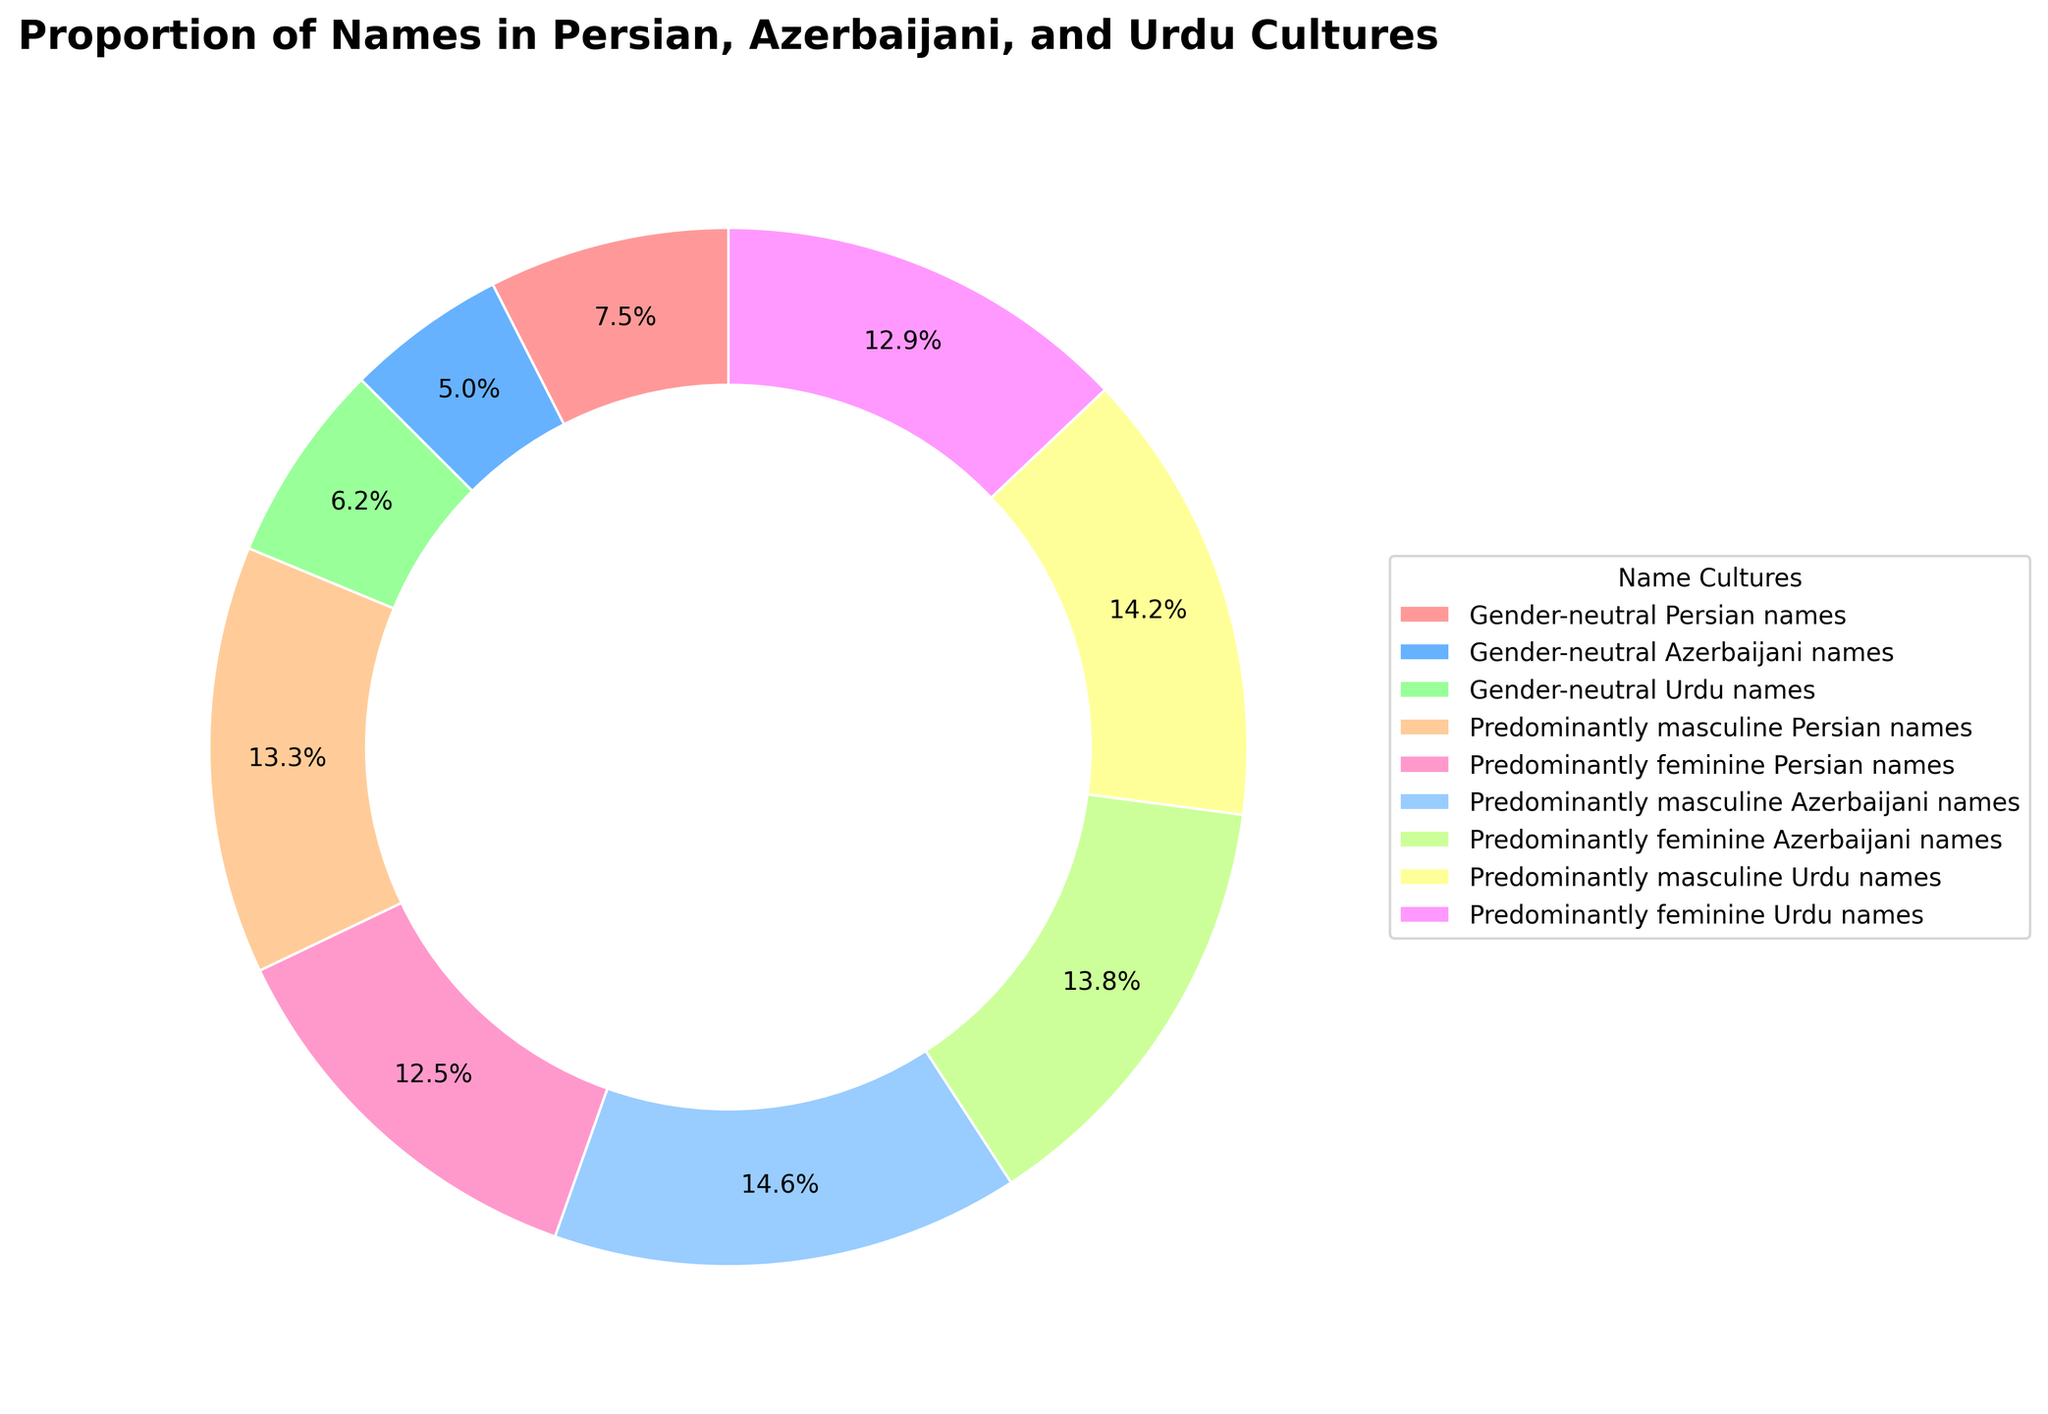What is the percentage of gender-neutral Persian names? The wedge labeled "Gender-neutral Persian names" in the pie chart shows 18%.
Answer: 18% Which culture has the smallest proportion of gender-neutral names? By comparing the wedges labeled "Gender-neutral Persian names", "Gender-neutral Azerbaijani names", and "Gender-neutral Urdu names", we see that Azerbaijani has the smallest at 12%.
Answer: Azerbaijani Is the proportion of gender-neutral Urdu names greater than that of gender-neutral Azerbaijani names? Yes, the wedge for "Gender-neutral Urdu names" is 15%, while "Gender-neutral Azerbaijani names" is 12%, thus Urdu names have a greater proportion.
Answer: Yes What is the combined percentage of predominantly masculine names across all three cultures? Sum the percentages of "Predominantly masculine Persian names" (32%), "Predominantly masculine Azerbaijani names" (35%), and "Predominantly masculine Urdu names" (34%). So, 32% + 35% + 34% = 101%.
Answer: 101% How much more prevalent are predominantly feminine Persian names than gender-neutral Persian names? Subtract the percentage of "Gender-neutral Persian names" (18%) from "Predominantly feminine Persian names" (30%). Thus, 30% - 18% = 12%.
Answer: 12% Which culture has the highest proportion of predominantly feminine names? By examining the wedges labeled for predominantly feminine names, "Predominantly feminine Azerbaijani names" at 33% is the highest.
Answer: Azerbaijani Compare the total percentage of gender-neutral names with the total percentage of predominantly feminine names across all cultures. Which is higher? First, sum the percentages for gender-neutral names: 18% (Persian) + 12% (Azerbaijani) + 15% (Urdu) = 45%. Next, sum the percentages for predominantly feminine names: 30% (Persian) + 33% (Azerbaijani) + 31% (Urdu) = 94%. Predominantly feminine names have a higher total percentage.
Answer: Predominantly feminine names By how much do the predominantly masculine names in Azerbaijani culture exceed the gender-neutral names in the same culture? Subtract the percentage of "Gender-neutral Azerbaijani names" (12%) from "Predominantly masculine Azerbaijani names" (35%). Thus, 35% - 12% = 23%.
Answer: 23% If the entire pie chart represents 100%, what fraction is made up of predominantly feminine names among all cultures combined? Adding the slices of predominantly feminine names (30% + 33% + 31%), we get 94%. To find the fraction, it is 94/100, which simplifies to 47/50 in fractional form.
Answer: 47/50 